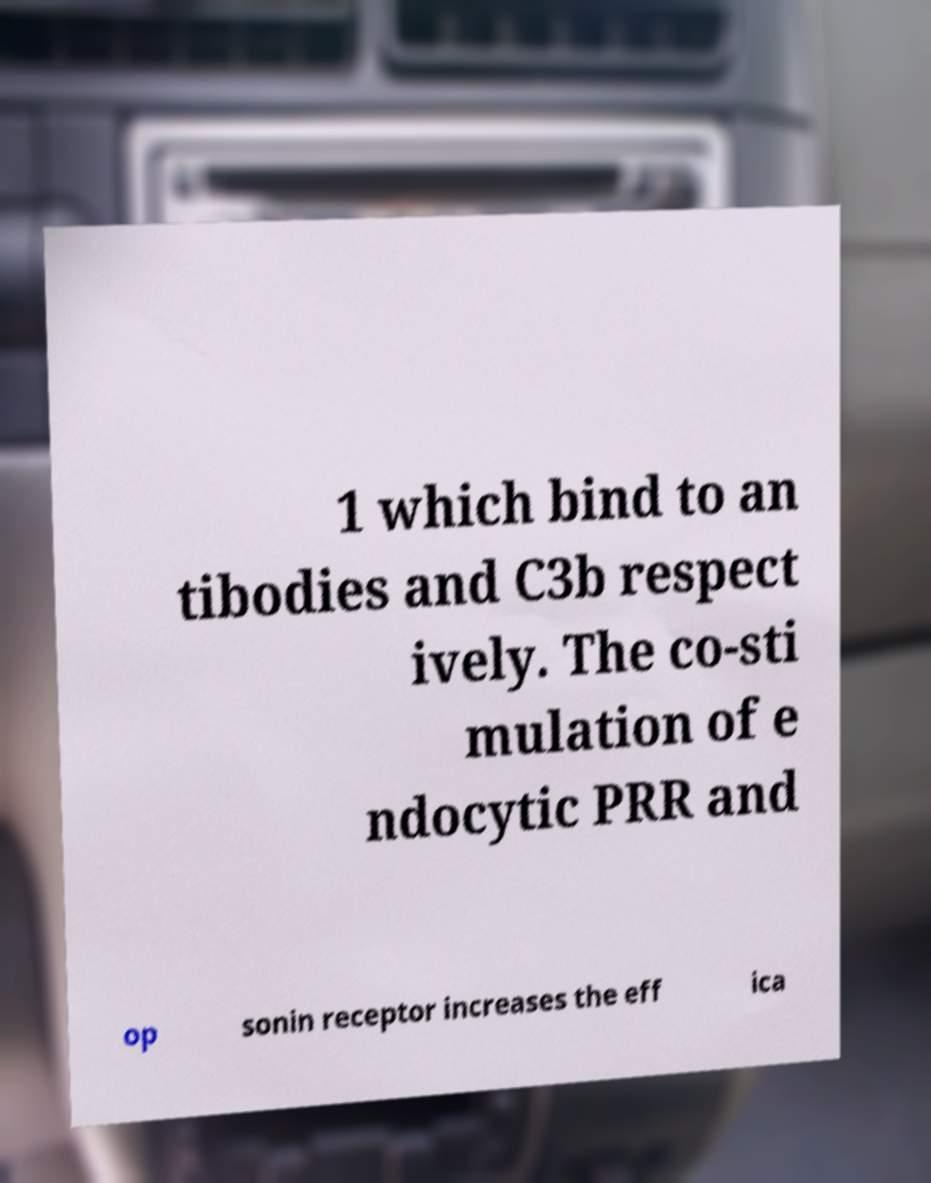Please read and relay the text visible in this image. What does it say? 1 which bind to an tibodies and C3b respect ively. The co-sti mulation of e ndocytic PRR and op sonin receptor increases the eff ica 